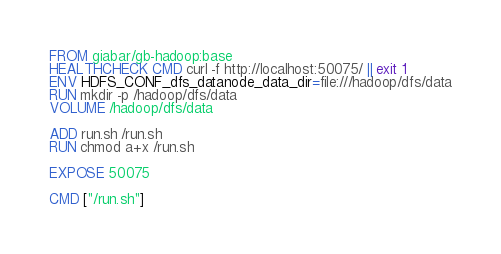Convert code to text. <code><loc_0><loc_0><loc_500><loc_500><_Dockerfile_>FROM giabar/gb-hadoop:base
HEALTHCHECK CMD curl -f http://localhost:50075/ || exit 1
ENV HDFS_CONF_dfs_datanode_data_dir=file:///hadoop/dfs/data
RUN mkdir -p /hadoop/dfs/data
VOLUME /hadoop/dfs/data

ADD run.sh /run.sh
RUN chmod a+x /run.sh

EXPOSE 50075

CMD ["/run.sh"]
</code> 